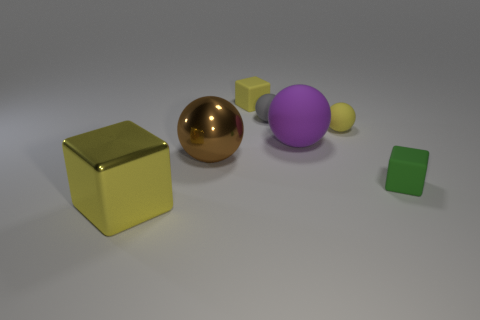Subtract all red spheres. Subtract all gray cylinders. How many spheres are left? 4 Add 1 brown balls. How many objects exist? 8 Subtract all blocks. How many objects are left? 4 Add 5 gray balls. How many gray balls are left? 6 Add 2 yellow metal cubes. How many yellow metal cubes exist? 3 Subtract 2 yellow blocks. How many objects are left? 5 Subtract all small purple rubber things. Subtract all large purple things. How many objects are left? 6 